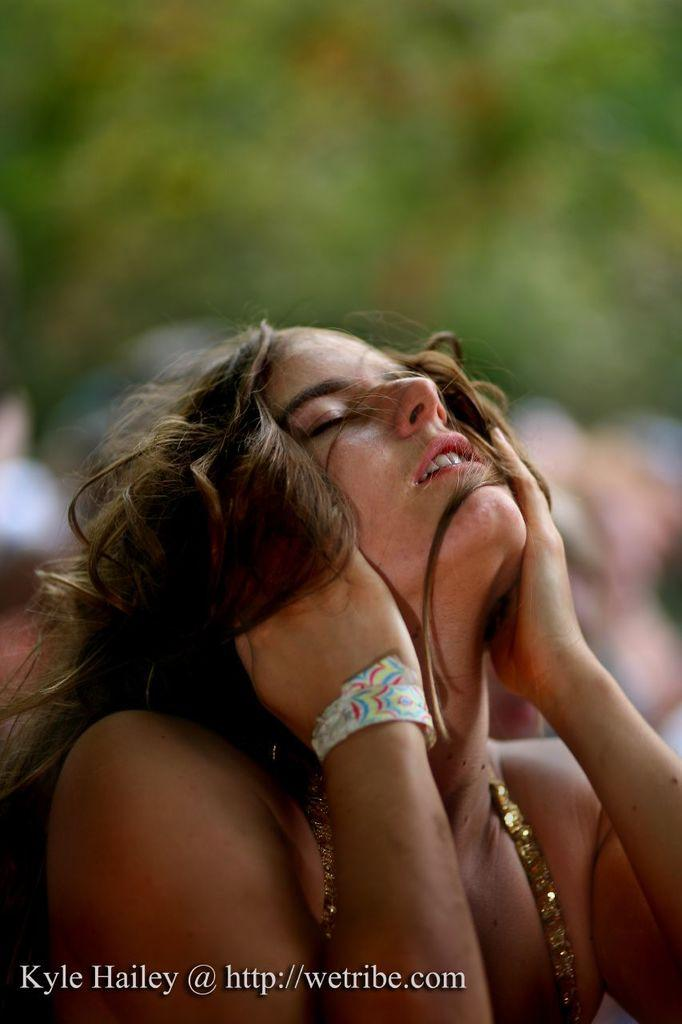Who is the main subject in the image? There is a woman in the center of the image. What can be seen in the background of the image? There are people and trees in the background of the image. Is there any text present in the image? Yes, there is text at the bottom of the image. How many ducks are present in the image? There are no ducks present in the image. What is the value of the woman's necklace in the image? The image does not provide any information about the value of the woman's necklace, nor is there any necklace visible in the image. 